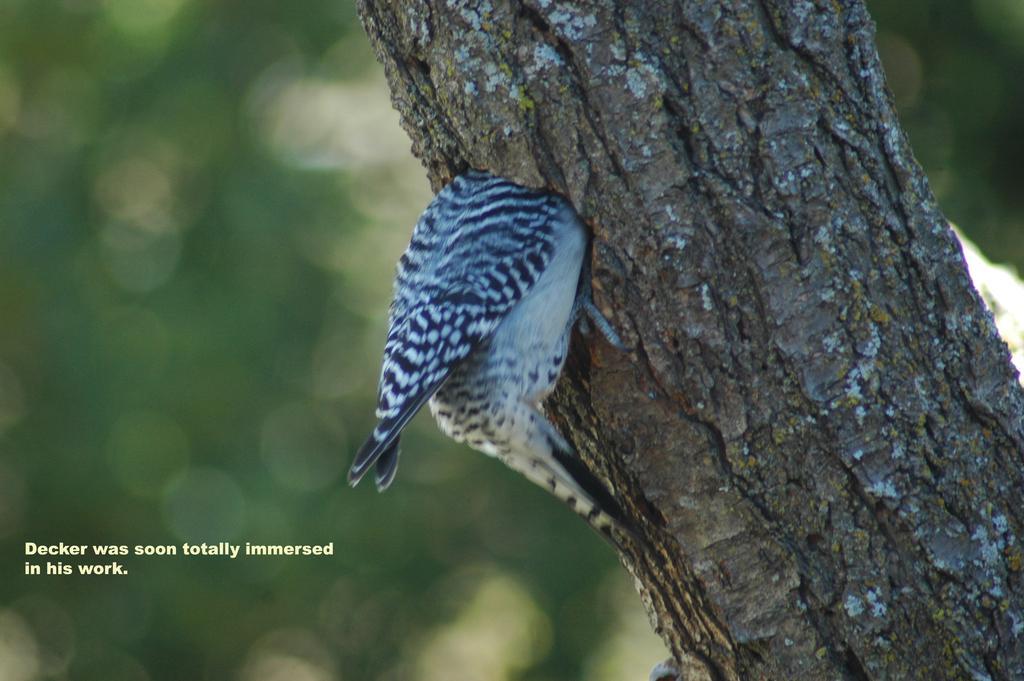How would you summarize this image in a sentence or two? In this image we can see a trunk of the tree. There is a bird in the image. There is some text written at the bottom of the image. 